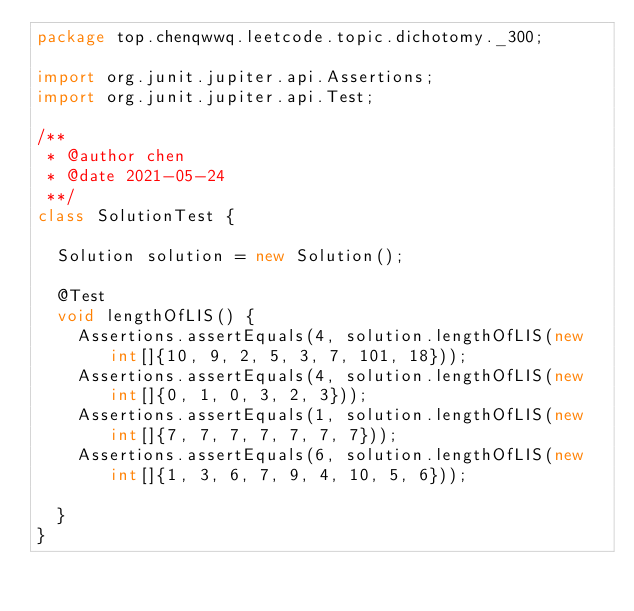Convert code to text. <code><loc_0><loc_0><loc_500><loc_500><_Java_>package top.chenqwwq.leetcode.topic.dichotomy._300;

import org.junit.jupiter.api.Assertions;
import org.junit.jupiter.api.Test;

/**
 * @author chen
 * @date 2021-05-24
 **/
class SolutionTest {

	Solution solution = new Solution();

	@Test
	void lengthOfLIS() {
		Assertions.assertEquals(4, solution.lengthOfLIS(new int[]{10, 9, 2, 5, 3, 7, 101, 18}));
		Assertions.assertEquals(4, solution.lengthOfLIS(new int[]{0, 1, 0, 3, 2, 3}));
		Assertions.assertEquals(1, solution.lengthOfLIS(new int[]{7, 7, 7, 7, 7, 7, 7}));
		Assertions.assertEquals(6, solution.lengthOfLIS(new int[]{1, 3, 6, 7, 9, 4, 10, 5, 6}));

	}
}</code> 